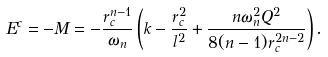<formula> <loc_0><loc_0><loc_500><loc_500>E ^ { c } = - M = - \frac { r _ { c } ^ { n - 1 } } { \omega _ { n } } \left ( k - \frac { r _ { c } ^ { 2 } } { l ^ { 2 } } + \frac { n \omega _ { n } ^ { 2 } Q ^ { 2 } } { 8 ( n - 1 ) r _ { c } ^ { 2 n - 2 } } \right ) .</formula> 